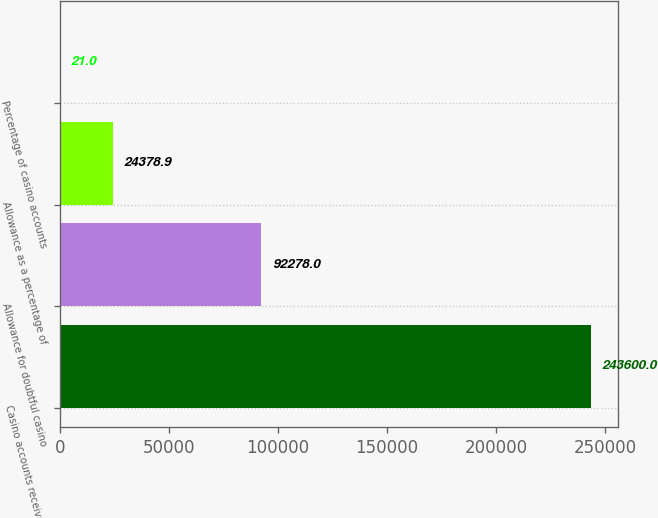Convert chart to OTSL. <chart><loc_0><loc_0><loc_500><loc_500><bar_chart><fcel>Casino accounts receivable<fcel>Allowance for doubtful casino<fcel>Allowance as a percentage of<fcel>Percentage of casino accounts<nl><fcel>243600<fcel>92278<fcel>24378.9<fcel>21<nl></chart> 